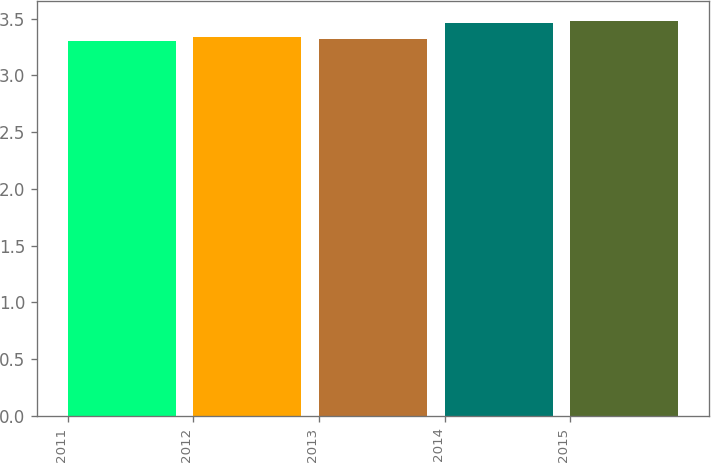Convert chart to OTSL. <chart><loc_0><loc_0><loc_500><loc_500><bar_chart><fcel>2011<fcel>2012<fcel>2013<fcel>2014<fcel>2015<nl><fcel>3.3<fcel>3.34<fcel>3.32<fcel>3.46<fcel>3.48<nl></chart> 